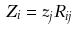Convert formula to latex. <formula><loc_0><loc_0><loc_500><loc_500>Z _ { i } = z _ { j } R _ { i j }</formula> 